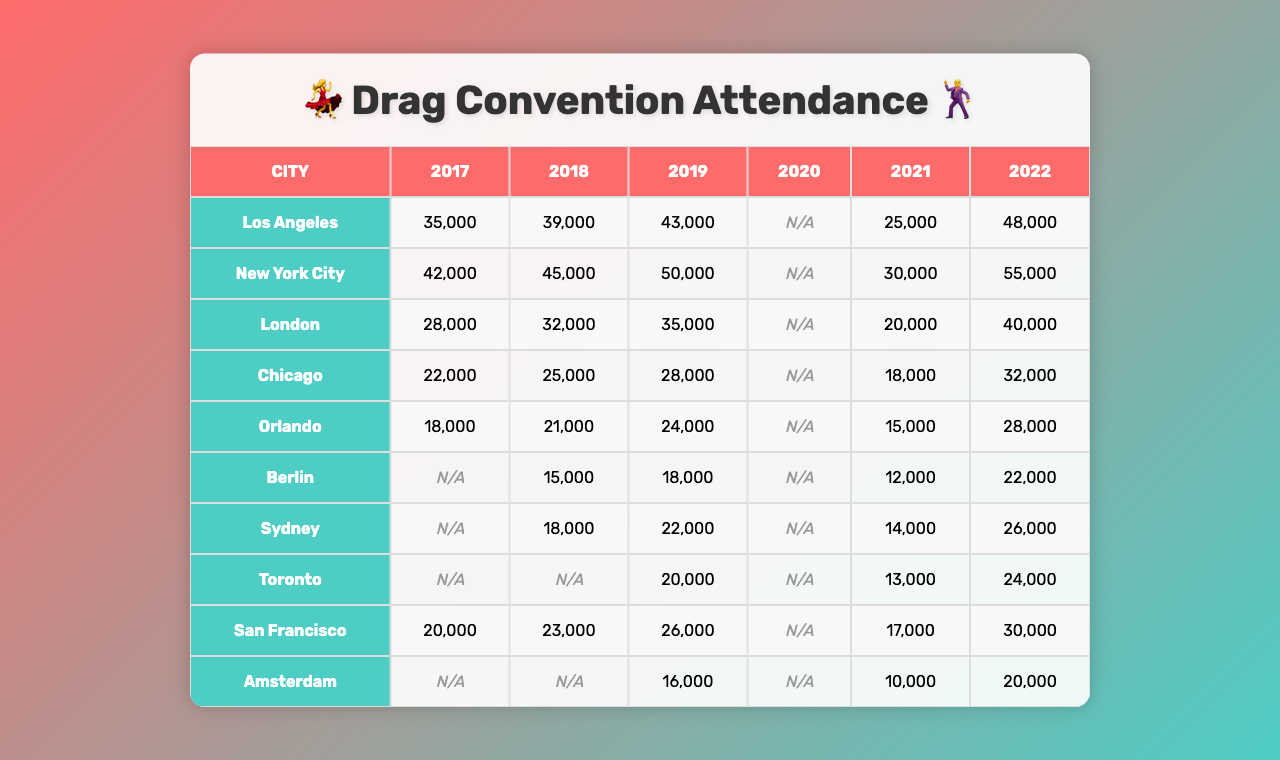What was the attendance in Los Angeles in 2022? The table shows that the attendance for Los Angeles in 2022 was 48,000.
Answer: 48,000 What year had the highest attendance in New York City? By looking at the data for New York City, the highest attendance occurred in 2022 with 55,000 attendees.
Answer: 2022 What is the total attendance across all cities in 2019? To find the total attendance for 2019, we add the attendance figures for each city: 43,000 + 50,000 + 35,000 + 28,000 + 24,000 + 18,000 + 22,000 + 20,000 + 26,000 + 16,000 =  292,000.
Answer: 292,000 Did Berlin have any attendance data in 2020? The table indicates that the attendance data for Berlin in 2020 is marked as N/A, meaning there was no available data.
Answer: No What was the average attendance for Chicago from 2017 to 2022? The attendance figures for Chicago are 22,000 (2017), 25,000 (2018), 28,000 (2019), N/A (2020), 18,000 (2021), and 32,000 (2022). We calculate the average using the entries that are not N/A: (22,000 + 25,000 + 28,000 + 18,000 + 32,000) / 5 = 25,000.
Answer: 25,000 Which city had the largest increase in attendance from 2018 to 2022? To find which city had the largest increase, we look at the attendance in 2018 and 2022. For example, Los Angeles had an increase of 48,000 - 39,000 = 9,000, and New York City had an increase of 55,000 - 45,000 = 10,000. The city with the largest increase is New York City.
Answer: New York City How many cities had attendance figures for all six years? By examining the data, only New York City, Chicago, and Los Angeles have attendance figures for all six years.
Answer: Three cities What was the percentage decrease in attendance from 2019 to 2021 for Orlando? The attendance in 2019 for Orlando was 24,000 and in 2021 it was 15,000. The percentage decrease is calculated as [(24,000 - 15,000) / 24,000] * 100 = 37.5%.
Answer: 37.5% What is the difference in attendance between the highest and lowest in 2019? The highest attendance in 2019 was 50,000 (New York City) and the lowest was 16,000 (Berlin). The difference is 50,000 - 16,000 = 34,000.
Answer: 34,000 Is there a trend of increasing attendance in Toronto from 2017 to 2022? Looking at the attendance figures: 20,000 (2017), N/A (2018), 20,000 (2019), N/A (2020), 13,000 (2021), and 24,000 (2022), there is an overall increase from 2019 to 2022 after dips in 2020 and 2021. Thus, there is a trend upwards, especially from 2021 to 2022.
Answer: Yes 